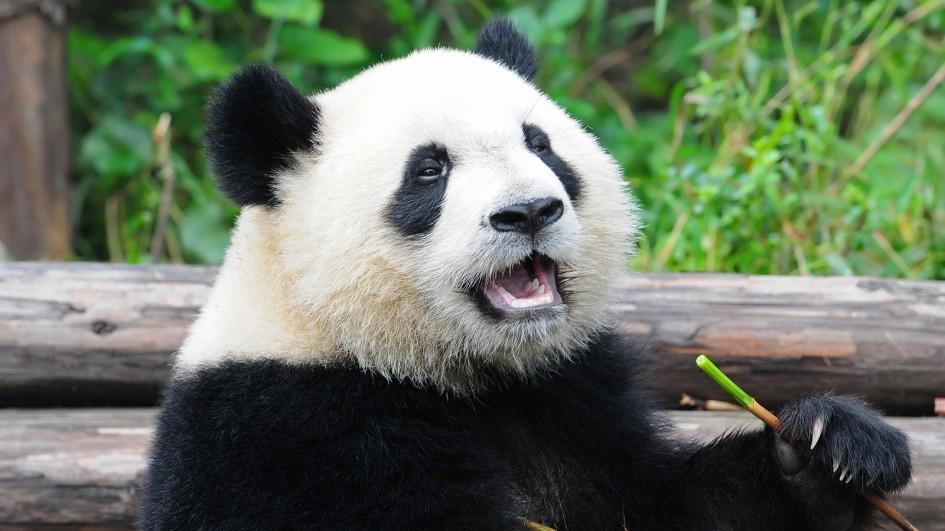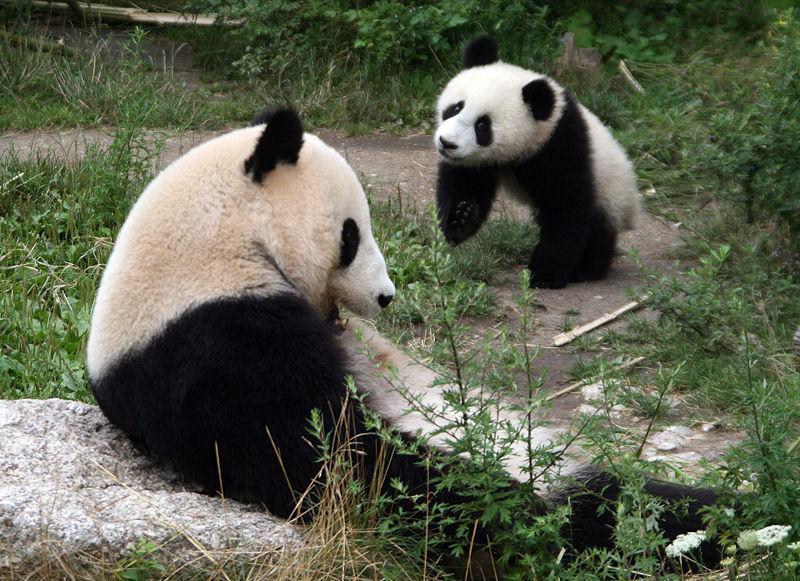The first image is the image on the left, the second image is the image on the right. Given the left and right images, does the statement "There are a total of three panda bears in these images." hold true? Answer yes or no. Yes. The first image is the image on the left, the second image is the image on the right. For the images displayed, is the sentence "There are three panda bears" factually correct? Answer yes or no. Yes. The first image is the image on the left, the second image is the image on the right. Examine the images to the left and right. Is the description "A panda has its chin on a surface." accurate? Answer yes or no. No. 